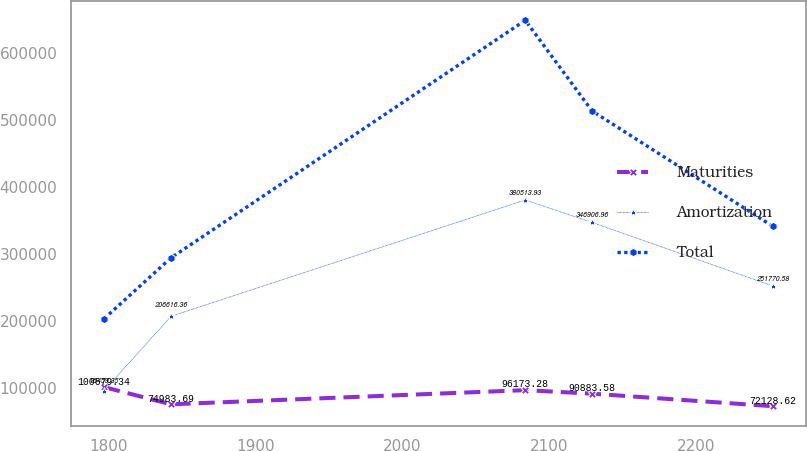Convert chart to OTSL. <chart><loc_0><loc_0><loc_500><loc_500><line_chart><ecel><fcel>Maturities<fcel>Amortization<fcel>Total<nl><fcel>1797.17<fcel>100679<fcel>95459.4<fcel>203068<nl><fcel>1842.68<fcel>74983.7<fcel>206616<fcel>294008<nl><fcel>2083.7<fcel>96173.3<fcel>380514<fcel>649148<nl><fcel>2129.21<fcel>90883.6<fcel>346907<fcel>513571<nl><fcel>2252.28<fcel>72128.6<fcel>251771<fcel>340929<nl></chart> 